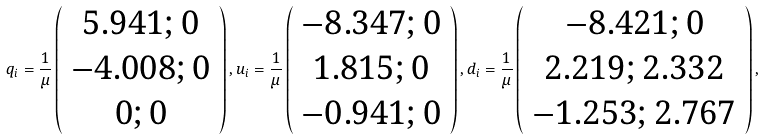Convert formula to latex. <formula><loc_0><loc_0><loc_500><loc_500>q _ { i } = \frac { 1 } { \mu } \left ( \begin{array} { c } 5 . 9 4 1 ; 0 \\ - 4 . 0 0 8 ; 0 \\ 0 ; 0 \end{array} \right ) , u _ { i } = \frac { 1 } { \mu } \left ( \begin{array} { c } - 8 . 3 4 7 ; 0 \\ 1 . 8 1 5 ; 0 \\ - 0 . 9 4 1 ; 0 \end{array} \right ) , d _ { i } = \frac { 1 } { \mu } \left ( \begin{array} { c } - 8 . 4 2 1 ; 0 \\ 2 . 2 1 9 ; 2 . 3 3 2 \\ - 1 . 2 5 3 ; 2 . 7 6 7 \end{array} \right ) ,</formula> 